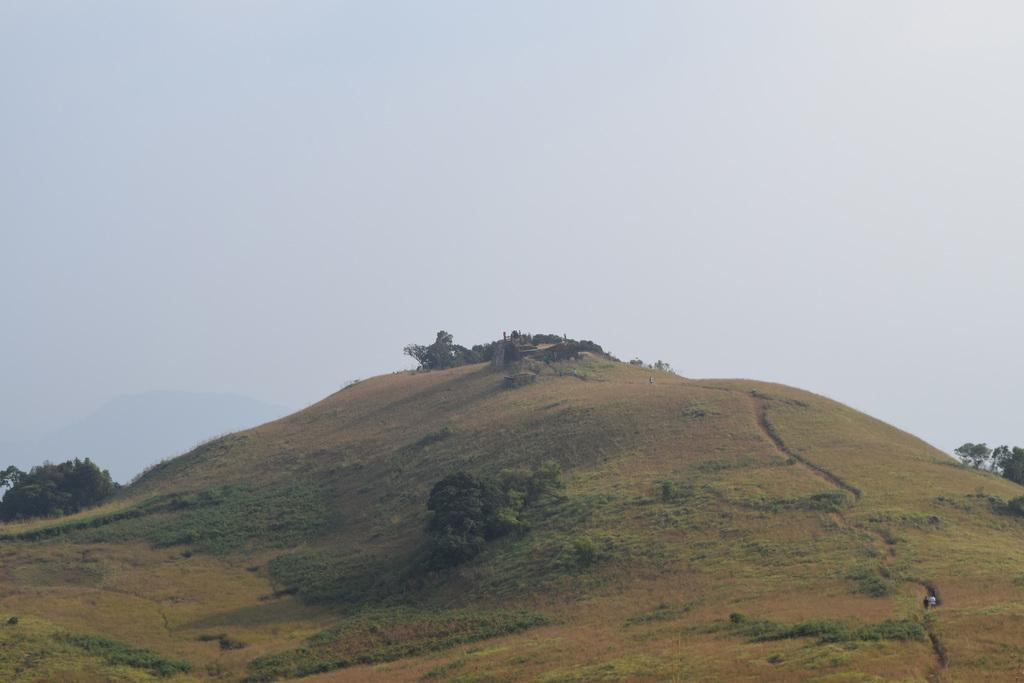Where was the picture taken? The picture was clicked outside. What can be seen in the foreground of the image? There is grass, plants, and a rock in the foreground of the image. Are there any objects in the foreground of the image? Yes, there are objects in the foreground of the image. What can be seen in the background of the image? The sky is visible in the background of the image. What type of agreement is being signed by the plants in the foreground of the image? There is no agreement being signed in the image; it features plants, grass, and a rock in the foreground. Can you see a sail in the image? There is no sail present in the image. 